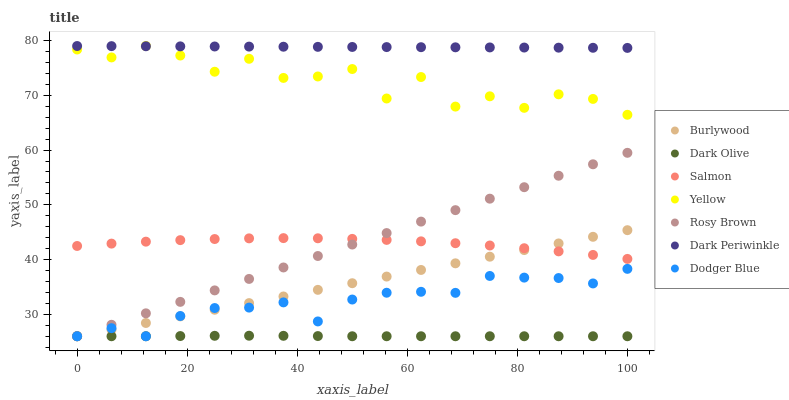Does Dark Olive have the minimum area under the curve?
Answer yes or no. Yes. Does Dark Periwinkle have the maximum area under the curve?
Answer yes or no. Yes. Does Burlywood have the minimum area under the curve?
Answer yes or no. No. Does Burlywood have the maximum area under the curve?
Answer yes or no. No. Is Burlywood the smoothest?
Answer yes or no. Yes. Is Yellow the roughest?
Answer yes or no. Yes. Is Rosy Brown the smoothest?
Answer yes or no. No. Is Rosy Brown the roughest?
Answer yes or no. No. Does Dark Olive have the lowest value?
Answer yes or no. Yes. Does Salmon have the lowest value?
Answer yes or no. No. Does Dark Periwinkle have the highest value?
Answer yes or no. Yes. Does Burlywood have the highest value?
Answer yes or no. No. Is Dark Olive less than Salmon?
Answer yes or no. Yes. Is Yellow greater than Burlywood?
Answer yes or no. Yes. Does Yellow intersect Dark Periwinkle?
Answer yes or no. Yes. Is Yellow less than Dark Periwinkle?
Answer yes or no. No. Is Yellow greater than Dark Periwinkle?
Answer yes or no. No. Does Dark Olive intersect Salmon?
Answer yes or no. No. 